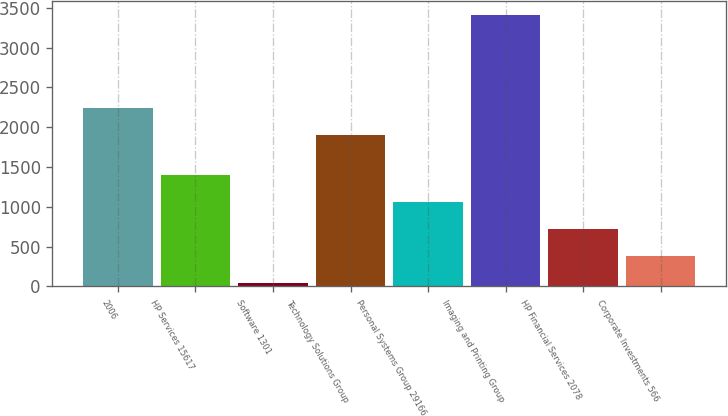<chart> <loc_0><loc_0><loc_500><loc_500><bar_chart><fcel>2006<fcel>HP Services 15617<fcel>Software 1301<fcel>Technology Solutions Group<fcel>Personal Systems Group 29166<fcel>Imaging and Printing Group<fcel>HP Financial Services 2078<fcel>Corporate Investments 566<nl><fcel>2238.4<fcel>1394.6<fcel>49<fcel>1902<fcel>1058.2<fcel>3413<fcel>721.8<fcel>385.4<nl></chart> 